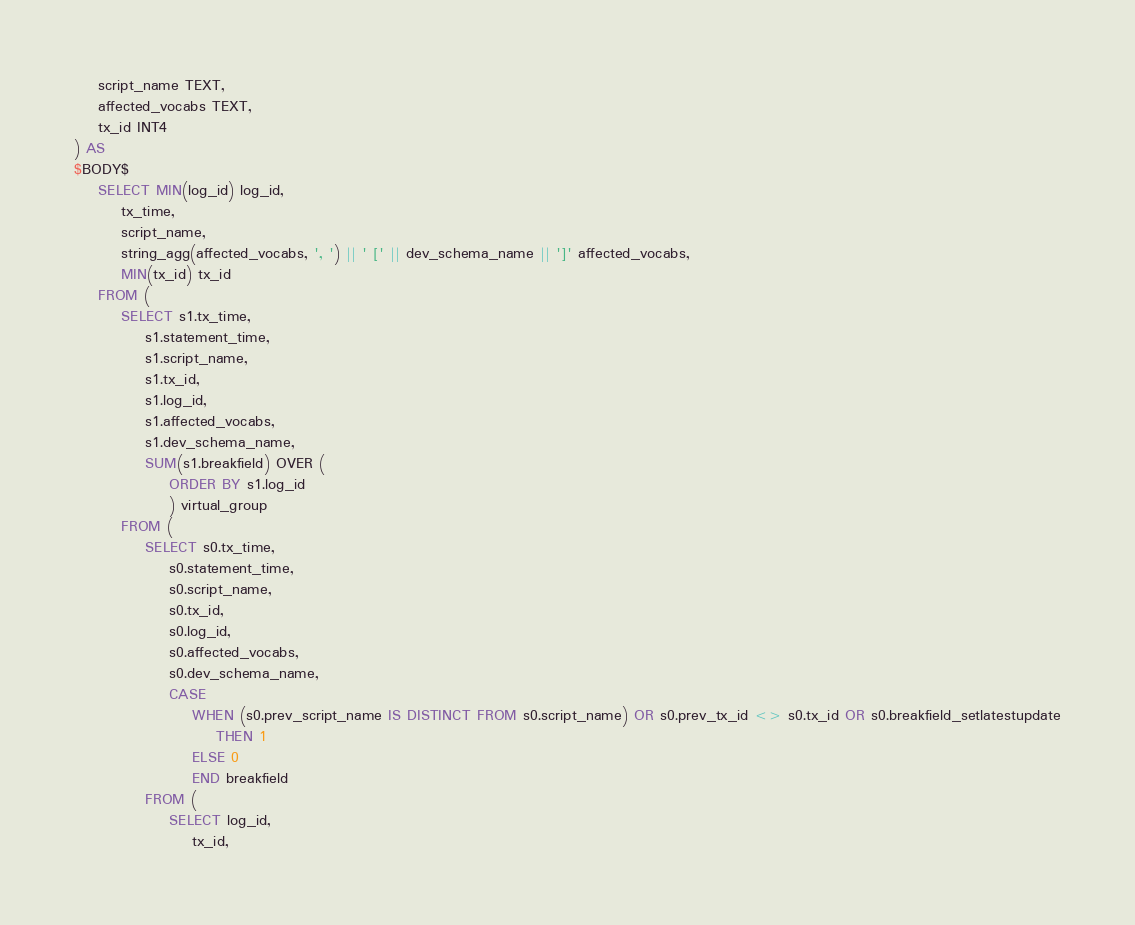<code> <loc_0><loc_0><loc_500><loc_500><_SQL_>	script_name TEXT,
	affected_vocabs TEXT,
	tx_id INT4
) AS
$BODY$
	SELECT MIN(log_id) log_id,
		tx_time,
		script_name,
		string_agg(affected_vocabs, ', ') || ' [' || dev_schema_name || ']' affected_vocabs,
		MIN(tx_id) tx_id
	FROM (
		SELECT s1.tx_time,
			s1.statement_time,
			s1.script_name,
			s1.tx_id,
			s1.log_id,
			s1.affected_vocabs,
			s1.dev_schema_name,
			SUM(s1.breakfield) OVER (
				ORDER BY s1.log_id
				) virtual_group
		FROM (
			SELECT s0.tx_time,
				s0.statement_time,
				s0.script_name,
				s0.tx_id,
				s0.log_id,
				s0.affected_vocabs,
				s0.dev_schema_name,
				CASE 
					WHEN (s0.prev_script_name IS DISTINCT FROM s0.script_name) OR s0.prev_tx_id <> s0.tx_id OR s0.breakfield_setlatestupdate
						THEN 1
					ELSE 0
					END breakfield
			FROM (
				SELECT log_id,
					tx_id,</code> 